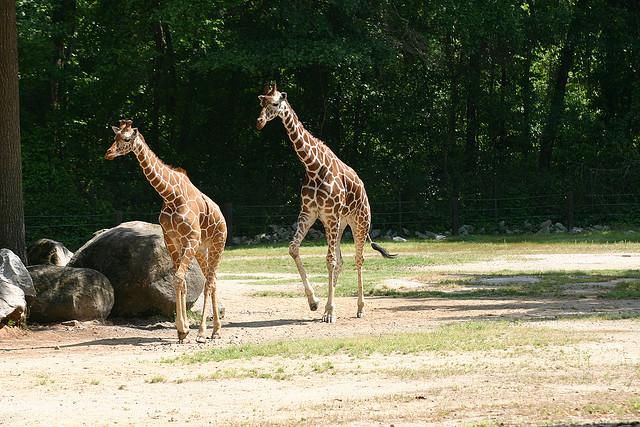How many animals can be seen?
Answer briefly. 2. How many giraffes are there?
Be succinct. 2. How old is the giraffe?
Write a very short answer. Young. Is the animal thirsty?
Give a very brief answer. No. Where do these animals live?
Concise answer only. Zoo. What is the giraffe doing?
Quick response, please. Walking. 